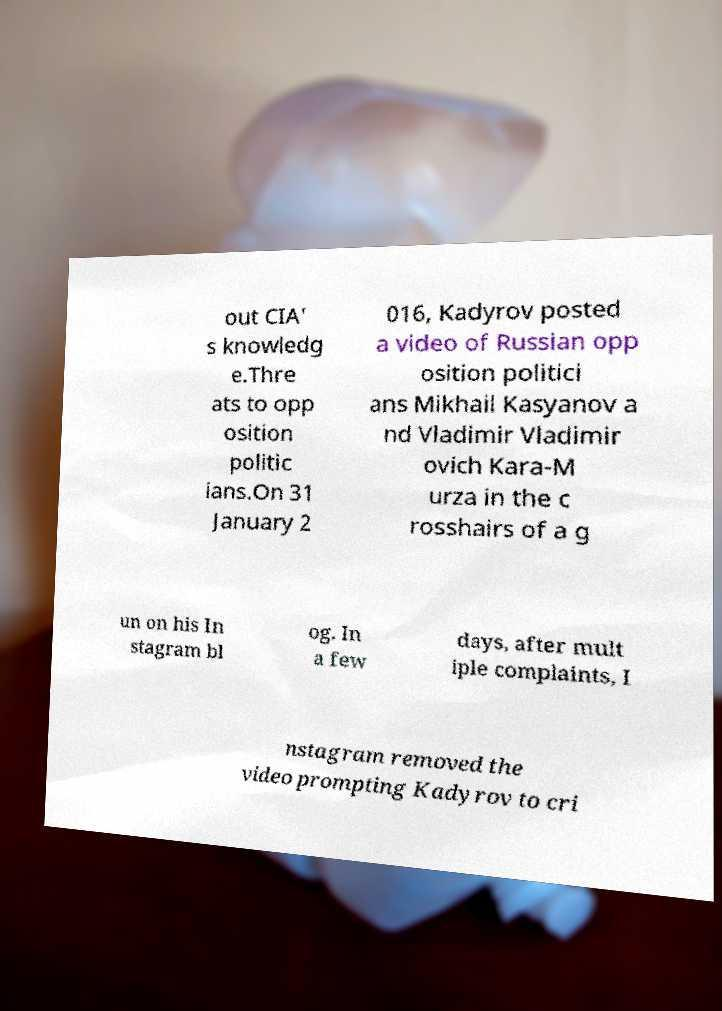For documentation purposes, I need the text within this image transcribed. Could you provide that? out CIA' s knowledg e.Thre ats to opp osition politic ians.On 31 January 2 016, Kadyrov posted a video of Russian opp osition politici ans Mikhail Kasyanov a nd Vladimir Vladimir ovich Kara-M urza in the c rosshairs of a g un on his In stagram bl og. In a few days, after mult iple complaints, I nstagram removed the video prompting Kadyrov to cri 